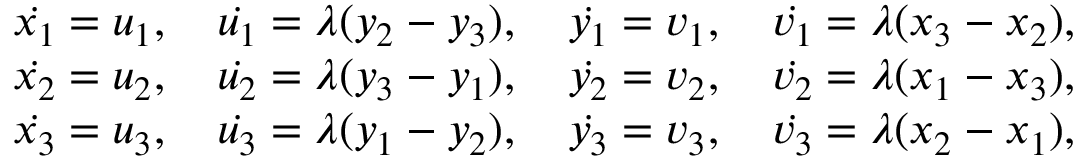Convert formula to latex. <formula><loc_0><loc_0><loc_500><loc_500>\begin{array} { r l } & { \dot { x _ { 1 } } = u _ { 1 } , \quad \dot { u _ { 1 } } = \lambda ( y _ { 2 } - y _ { 3 } ) , \quad \dot { y _ { 1 } } = v _ { 1 } , \quad \dot { v _ { 1 } } = \lambda ( x _ { 3 } - x _ { 2 } ) , } \\ & { \dot { x _ { 2 } } = u _ { 2 } , \quad \dot { u _ { 2 } } = \lambda ( y _ { 3 } - y _ { 1 } ) , \quad \dot { y _ { 2 } } = v _ { 2 } , \quad \dot { v _ { 2 } } = \lambda ( x _ { 1 } - x _ { 3 } ) , } \\ & { \dot { x _ { 3 } } = u _ { 3 } , \quad \dot { u _ { 3 } } = \lambda ( y _ { 1 } - y _ { 2 } ) , \quad \dot { y _ { 3 } } = v _ { 3 } , \quad \dot { v _ { 3 } } = \lambda ( x _ { 2 } - x _ { 1 } ) , } \end{array}</formula> 